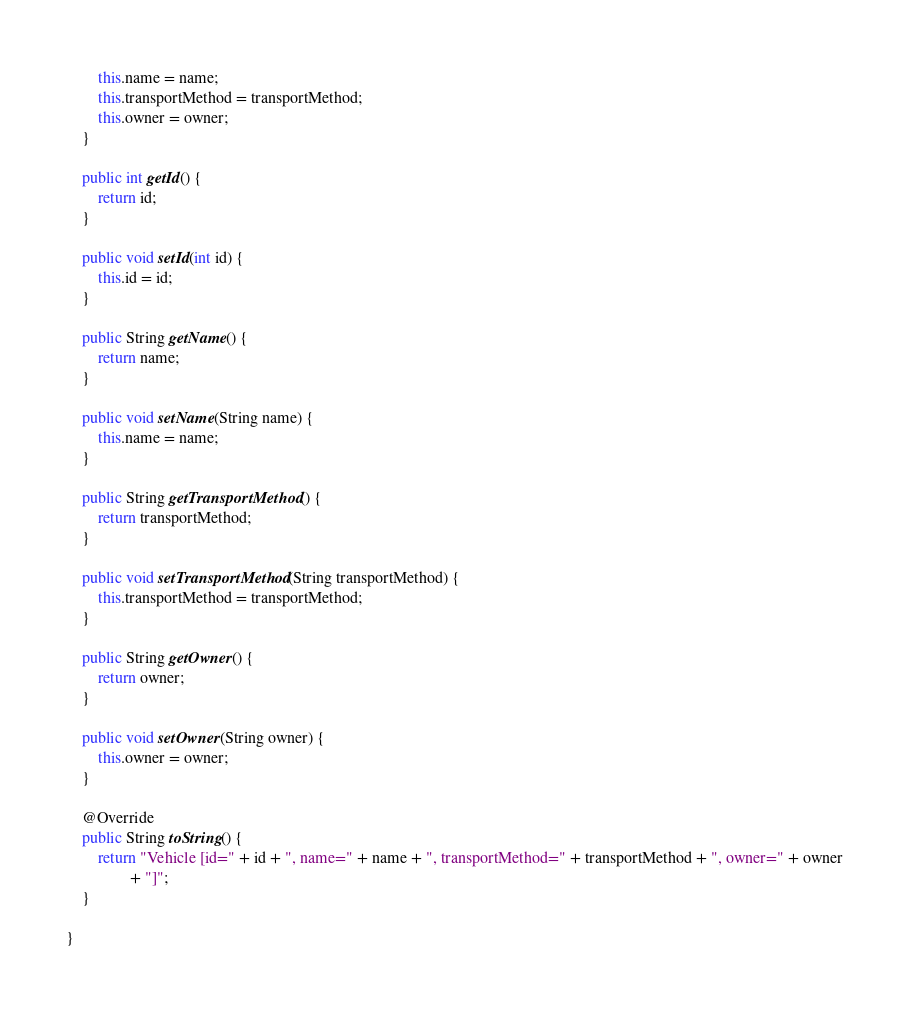<code> <loc_0><loc_0><loc_500><loc_500><_Java_>		this.name = name;
		this.transportMethod = transportMethod;
		this.owner = owner;
	}

	public int getId() {
		return id;
	}

	public void setId(int id) {
		this.id = id;
	}

	public String getName() {
		return name;
	}

	public void setName(String name) {
		this.name = name;
	}

	public String getTransportMethod() {
		return transportMethod;
	}

	public void setTransportMethod(String transportMethod) {
		this.transportMethod = transportMethod;
	}

	public String getOwner() {
		return owner;
	}

	public void setOwner(String owner) {
		this.owner = owner;
	}

	@Override
	public String toString() {
		return "Vehicle [id=" + id + ", name=" + name + ", transportMethod=" + transportMethod + ", owner=" + owner
				+ "]";
	}

}
</code> 